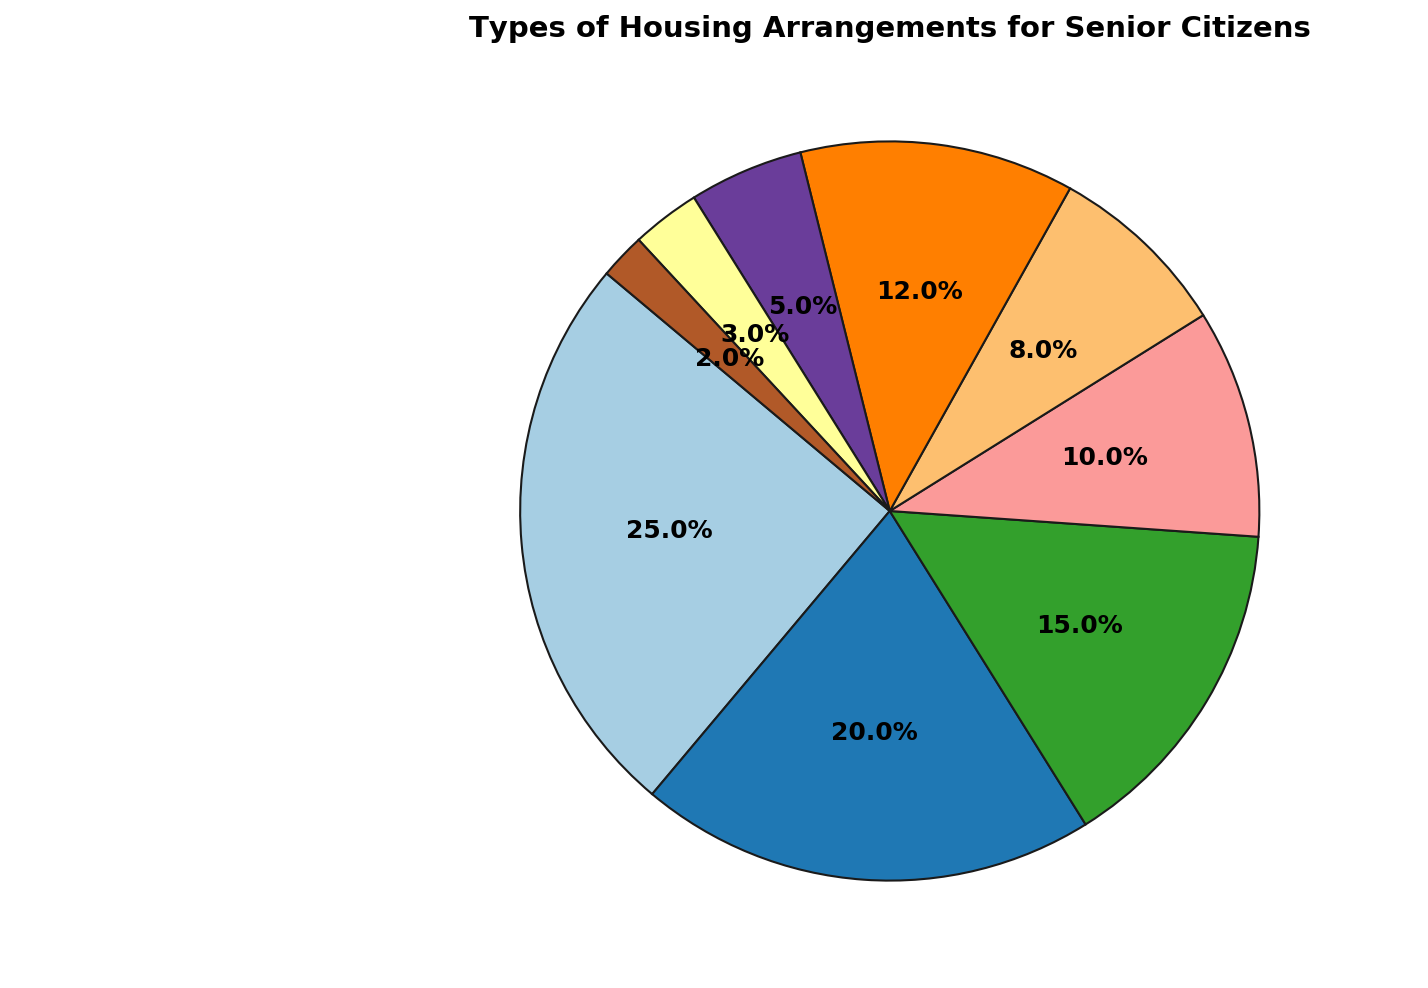Which type of housing arrangements for senior citizens has the highest percentage? To determine the type with the highest percentage, look for the largest slice in the pie chart. The 'Independent Living' slice is the largest, making it the type with the highest percentage.
Answer: Independent Living What is the combined percentage of 'Independent Living' and 'Assisted Living'? Sum the percentages for 'Independent Living' (25%) and 'Assisted Living' (20%). The total is 25 + 20 = 45%.
Answer: 45% How does the percentage of 'Memory Care Units' compare to the percentage of 'Residential Care Homes'? Observe the sizes of the slices representing 'Memory Care Units' and 'Residential Care Homes'. 'Memory Care Units' accounts for 5% while 'Residential Care Homes' is 3%. Thus, 'Memory Care Units' have a higher percentage.
Answer: Memory Care Units have a higher percentage What is the difference in percentage between 'Nursing Homes' and 'Home Care'? Find the percentages for 'Nursing Homes' (15%) and 'Home Care' (10%) and calculate the difference: 15 - 10 = 5%.
Answer: 5% Which housing arrangement has the smallest percentage, and what is it? Identify the smallest slice in the pie chart. 'Continuing Care Retirement Communities (CCRCs)' appears to be the smallest slice, at 2%.
Answer: Continuing Care Retirement Communities (CCRCs), 2% Combine the percentages of 'Senior Co-housing', 'Memory Care Units', and 'Residential Care Homes'. What do you get? Add the percentages of 'Senior Co-housing' (8%), 'Memory Care Units' (5%), and 'Residential Care Homes' (3%): 8 + 5 + 3 = 16%.
Answer: 16% Which type of housing is more common, 'Retirement Communities' or 'Home Care'? Compare the sizes of the slices for 'Retirement Communities' (12%) and 'Home Care' (10%). 'Retirement Communities' have a larger percentage.
Answer: Retirement Communities If we combine half of the 'Assisted Living' percentage with 'Home Care', what percentage would we get? Calculate half of the 'Assisted Living' percentage: 20 / 2 = 10%. Add this to the 'Home Care' percentage: 10 + 10 = 20%.
Answer: 20% How many types of housing have a percentage less than 10%? Count the slices that represent less than 10%. These are 'Home Care' (10%), 'Senior Co-housing' (8%), 'Memory Care Units' (5%), 'Residential Care Homes' (3%), and 'Continuing Care Retirement Communities (CCRCs)' (2%). Four types meet the criteria.
Answer: 4 types 